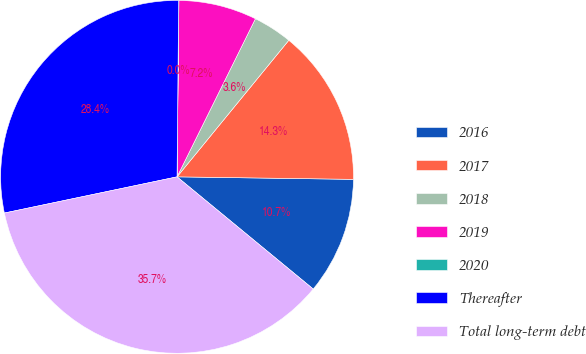Convert chart to OTSL. <chart><loc_0><loc_0><loc_500><loc_500><pie_chart><fcel>2016<fcel>2017<fcel>2018<fcel>2019<fcel>2020<fcel>Thereafter<fcel>Total long-term debt<nl><fcel>10.74%<fcel>14.31%<fcel>3.59%<fcel>7.16%<fcel>0.02%<fcel>28.43%<fcel>35.74%<nl></chart> 